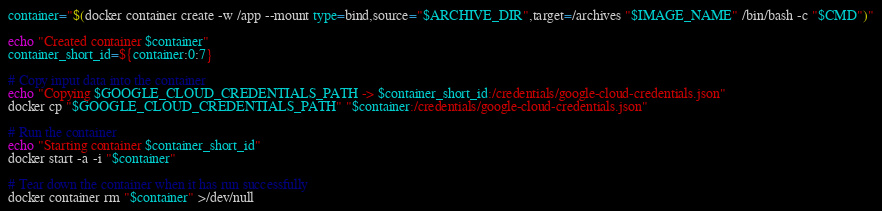<code> <loc_0><loc_0><loc_500><loc_500><_Bash_>container="$(docker container create -w /app --mount type=bind,source="$ARCHIVE_DIR",target=/archives "$IMAGE_NAME" /bin/bash -c "$CMD")"

echo "Created container $container"
container_short_id=${container:0:7}

# Copy input data into the container
echo "Copying $GOOGLE_CLOUD_CREDENTIALS_PATH -> $container_short_id:/credentials/google-cloud-credentials.json"
docker cp "$GOOGLE_CLOUD_CREDENTIALS_PATH" "$container:/credentials/google-cloud-credentials.json"

# Run the container
echo "Starting container $container_short_id"
docker start -a -i "$container"

# Tear down the container when it has run successfully
docker container rm "$container" >/dev/null
</code> 